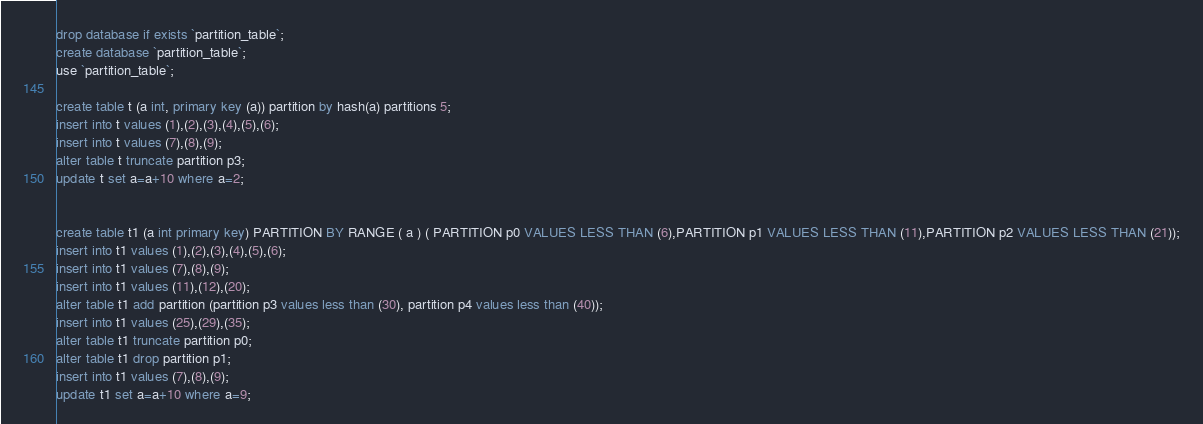Convert code to text. <code><loc_0><loc_0><loc_500><loc_500><_SQL_>drop database if exists `partition_table`;
create database `partition_table`;
use `partition_table`;

create table t (a int, primary key (a)) partition by hash(a) partitions 5;
insert into t values (1),(2),(3),(4),(5),(6);
insert into t values (7),(8),(9);
alter table t truncate partition p3;
update t set a=a+10 where a=2;


create table t1 (a int primary key) PARTITION BY RANGE ( a ) ( PARTITION p0 VALUES LESS THAN (6),PARTITION p1 VALUES LESS THAN (11),PARTITION p2 VALUES LESS THAN (21));
insert into t1 values (1),(2),(3),(4),(5),(6);
insert into t1 values (7),(8),(9);
insert into t1 values (11),(12),(20);
alter table t1 add partition (partition p3 values less than (30), partition p4 values less than (40));
insert into t1 values (25),(29),(35);
alter table t1 truncate partition p0;
alter table t1 drop partition p1;
insert into t1 values (7),(8),(9);
update t1 set a=a+10 where a=9;

</code> 